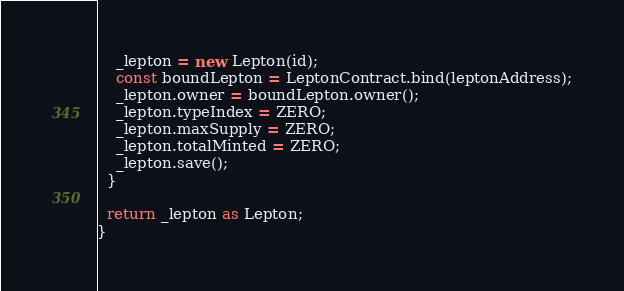<code> <loc_0><loc_0><loc_500><loc_500><_TypeScript_>    _lepton = new Lepton(id);
    const boundLepton = LeptonContract.bind(leptonAddress);
    _lepton.owner = boundLepton.owner();
    _lepton.typeIndex = ZERO;
    _lepton.maxSupply = ZERO;
    _lepton.totalMinted = ZERO;
    _lepton.save();
  }

  return _lepton as Lepton;
}
</code> 